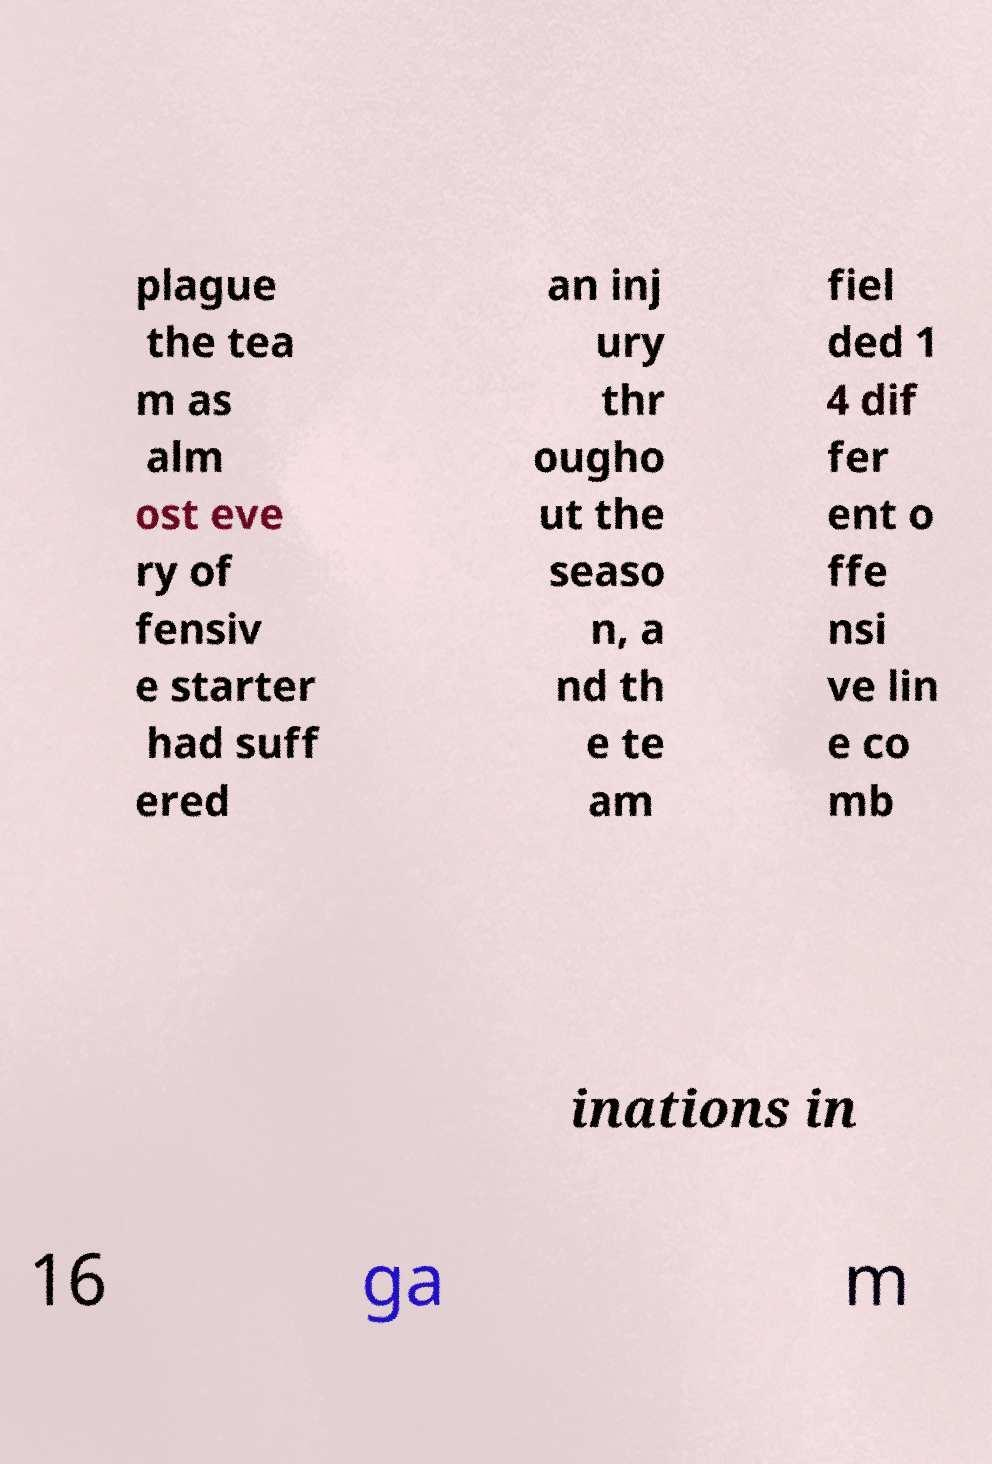I need the written content from this picture converted into text. Can you do that? plague the tea m as alm ost eve ry of fensiv e starter had suff ered an inj ury thr ougho ut the seaso n, a nd th e te am fiel ded 1 4 dif fer ent o ffe nsi ve lin e co mb inations in 16 ga m 